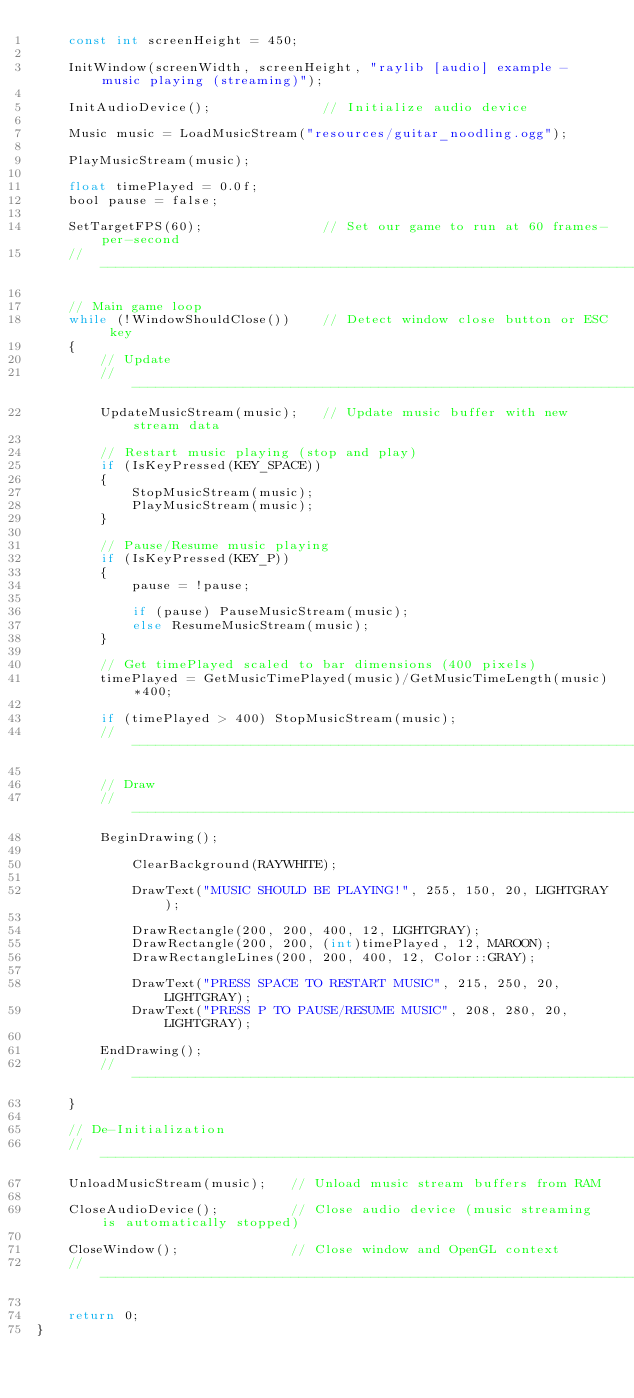<code> <loc_0><loc_0><loc_500><loc_500><_C_>    const int screenHeight = 450;

    InitWindow(screenWidth, screenHeight, "raylib [audio] example - music playing (streaming)");

    InitAudioDevice();              // Initialize audio device

    Music music = LoadMusicStream("resources/guitar_noodling.ogg");

    PlayMusicStream(music);

    float timePlayed = 0.0f;
    bool pause = false;

    SetTargetFPS(60);               // Set our game to run at 60 frames-per-second
    //--------------------------------------------------------------------------------------

    // Main game loop
    while (!WindowShouldClose())    // Detect window close button or ESC key
    {
        // Update
        //----------------------------------------------------------------------------------
        UpdateMusicStream(music);   // Update music buffer with new stream data

        // Restart music playing (stop and play)
        if (IsKeyPressed(KEY_SPACE))
        {
            StopMusicStream(music);
            PlayMusicStream(music);
        }

        // Pause/Resume music playing
        if (IsKeyPressed(KEY_P))
        {
            pause = !pause;

            if (pause) PauseMusicStream(music);
            else ResumeMusicStream(music);
        }

        // Get timePlayed scaled to bar dimensions (400 pixels)
        timePlayed = GetMusicTimePlayed(music)/GetMusicTimeLength(music)*400;

        if (timePlayed > 400) StopMusicStream(music);
        //----------------------------------------------------------------------------------

        // Draw
        //----------------------------------------------------------------------------------
        BeginDrawing();

            ClearBackground(RAYWHITE);

            DrawText("MUSIC SHOULD BE PLAYING!", 255, 150, 20, LIGHTGRAY);

            DrawRectangle(200, 200, 400, 12, LIGHTGRAY);
            DrawRectangle(200, 200, (int)timePlayed, 12, MAROON);
            DrawRectangleLines(200, 200, 400, 12, Color::GRAY);

            DrawText("PRESS SPACE TO RESTART MUSIC", 215, 250, 20, LIGHTGRAY);
            DrawText("PRESS P TO PAUSE/RESUME MUSIC", 208, 280, 20, LIGHTGRAY);

        EndDrawing();
        //----------------------------------------------------------------------------------
    }

    // De-Initialization
    //--------------------------------------------------------------------------------------
    UnloadMusicStream(music);   // Unload music stream buffers from RAM

    CloseAudioDevice();         // Close audio device (music streaming is automatically stopped)

    CloseWindow();              // Close window and OpenGL context
    //--------------------------------------------------------------------------------------

    return 0;
}</code> 